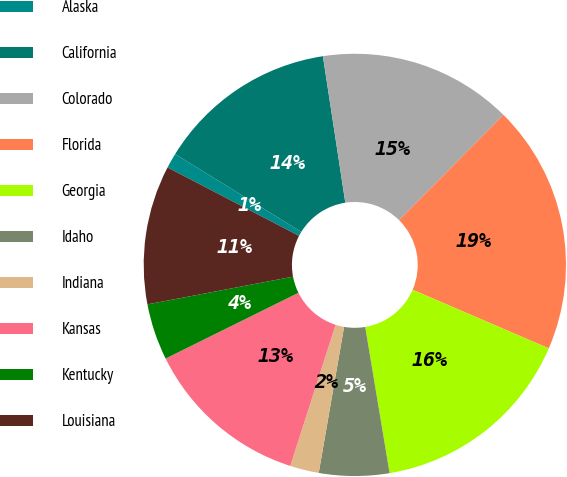<chart> <loc_0><loc_0><loc_500><loc_500><pie_chart><fcel>Alaska<fcel>California<fcel>Colorado<fcel>Florida<fcel>Georgia<fcel>Idaho<fcel>Indiana<fcel>Kansas<fcel>Kentucky<fcel>Louisiana<nl><fcel>1.16%<fcel>13.79%<fcel>14.84%<fcel>19.05%<fcel>15.9%<fcel>5.37%<fcel>2.21%<fcel>12.74%<fcel>4.32%<fcel>10.63%<nl></chart> 